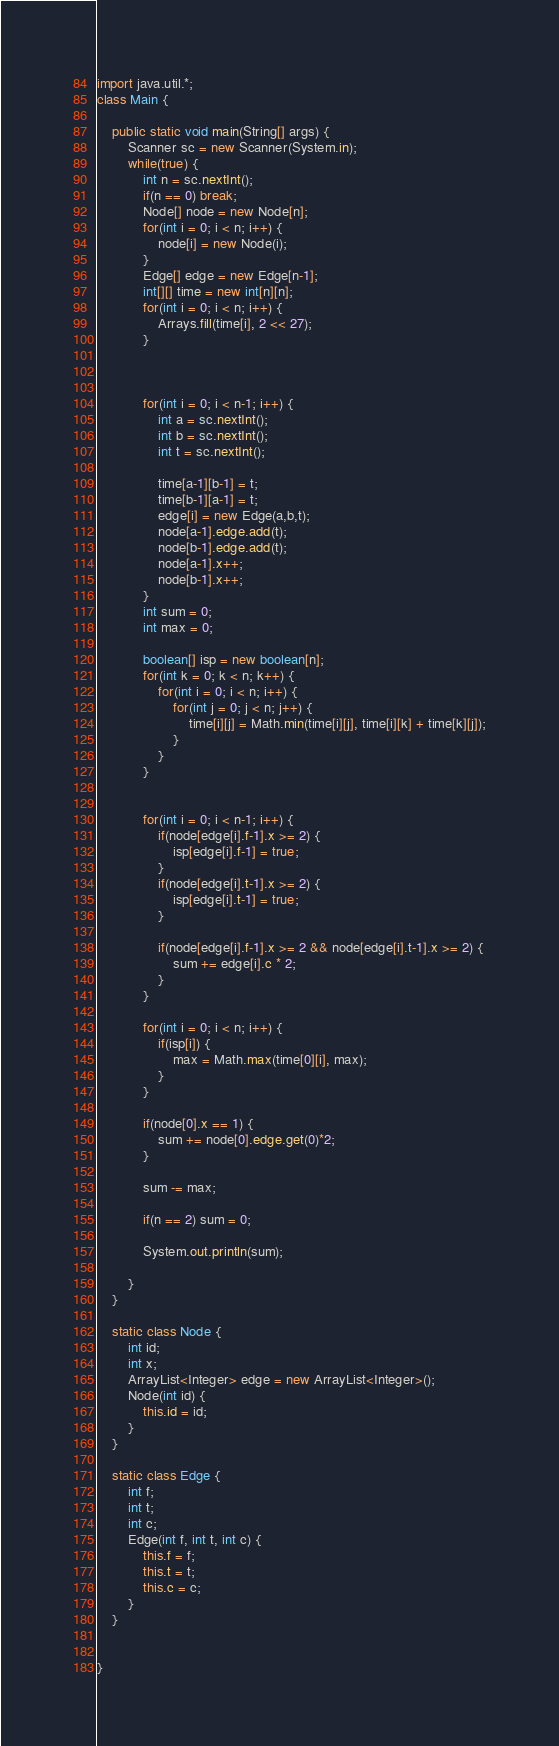<code> <loc_0><loc_0><loc_500><loc_500><_Java_>import java.util.*;
class Main {
	
	public static void main(String[] args) {
		Scanner sc = new Scanner(System.in);
		while(true) {
			int n = sc.nextInt();
			if(n == 0) break;
			Node[] node = new Node[n];
			for(int i = 0; i < n; i++) {
				node[i] = new Node(i);
			}
			Edge[] edge = new Edge[n-1];
			int[][] time = new int[n][n];
			for(int i = 0; i < n; i++) {
				Arrays.fill(time[i], 2 << 27);
			}
			
			
			
			for(int i = 0; i < n-1; i++) {
				int a = sc.nextInt();
				int b = sc.nextInt();
				int t = sc.nextInt();
				
				time[a-1][b-1] = t;
				time[b-1][a-1] = t;
				edge[i] = new Edge(a,b,t);
				node[a-1].edge.add(t);
				node[b-1].edge.add(t);		
				node[a-1].x++;
				node[b-1].x++;
			}
			int sum = 0;
			int max = 0;
			
			boolean[] isp = new boolean[n];
			for(int k = 0; k < n; k++) {
				for(int i = 0; i < n; i++) {
					for(int j = 0; j < n; j++) {
						time[i][j] = Math.min(time[i][j], time[i][k] + time[k][j]);
					}
				}
			}
			

			for(int i = 0; i < n-1; i++) {
				if(node[edge[i].f-1].x >= 2) {
					isp[edge[i].f-1] = true;
				}
				if(node[edge[i].t-1].x >= 2) {
					isp[edge[i].t-1] = true;
				}
				
				if(node[edge[i].f-1].x >= 2 && node[edge[i].t-1].x >= 2) {
					sum += edge[i].c * 2;
				}
			}
			
			for(int i = 0; i < n; i++) {
				if(isp[i]) {
					max = Math.max(time[0][i], max);
				}
			}
			
			if(node[0].x == 1) {
				sum += node[0].edge.get(0)*2;
			}
			
			sum -= max;
			
			if(n == 2) sum = 0;
			
			System.out.println(sum);
		
		}
	}
	
	static class Node {
		int id;
		int x;
		ArrayList<Integer> edge = new ArrayList<Integer>();
		Node(int id) {
			this.id = id;
		}
	}
	
	static class Edge {
		int f;
		int t;
		int c;
		Edge(int f, int t, int c) {
			this.f = f;
			this.t = t;
			this.c = c;
		}
	}
	
	
}</code> 